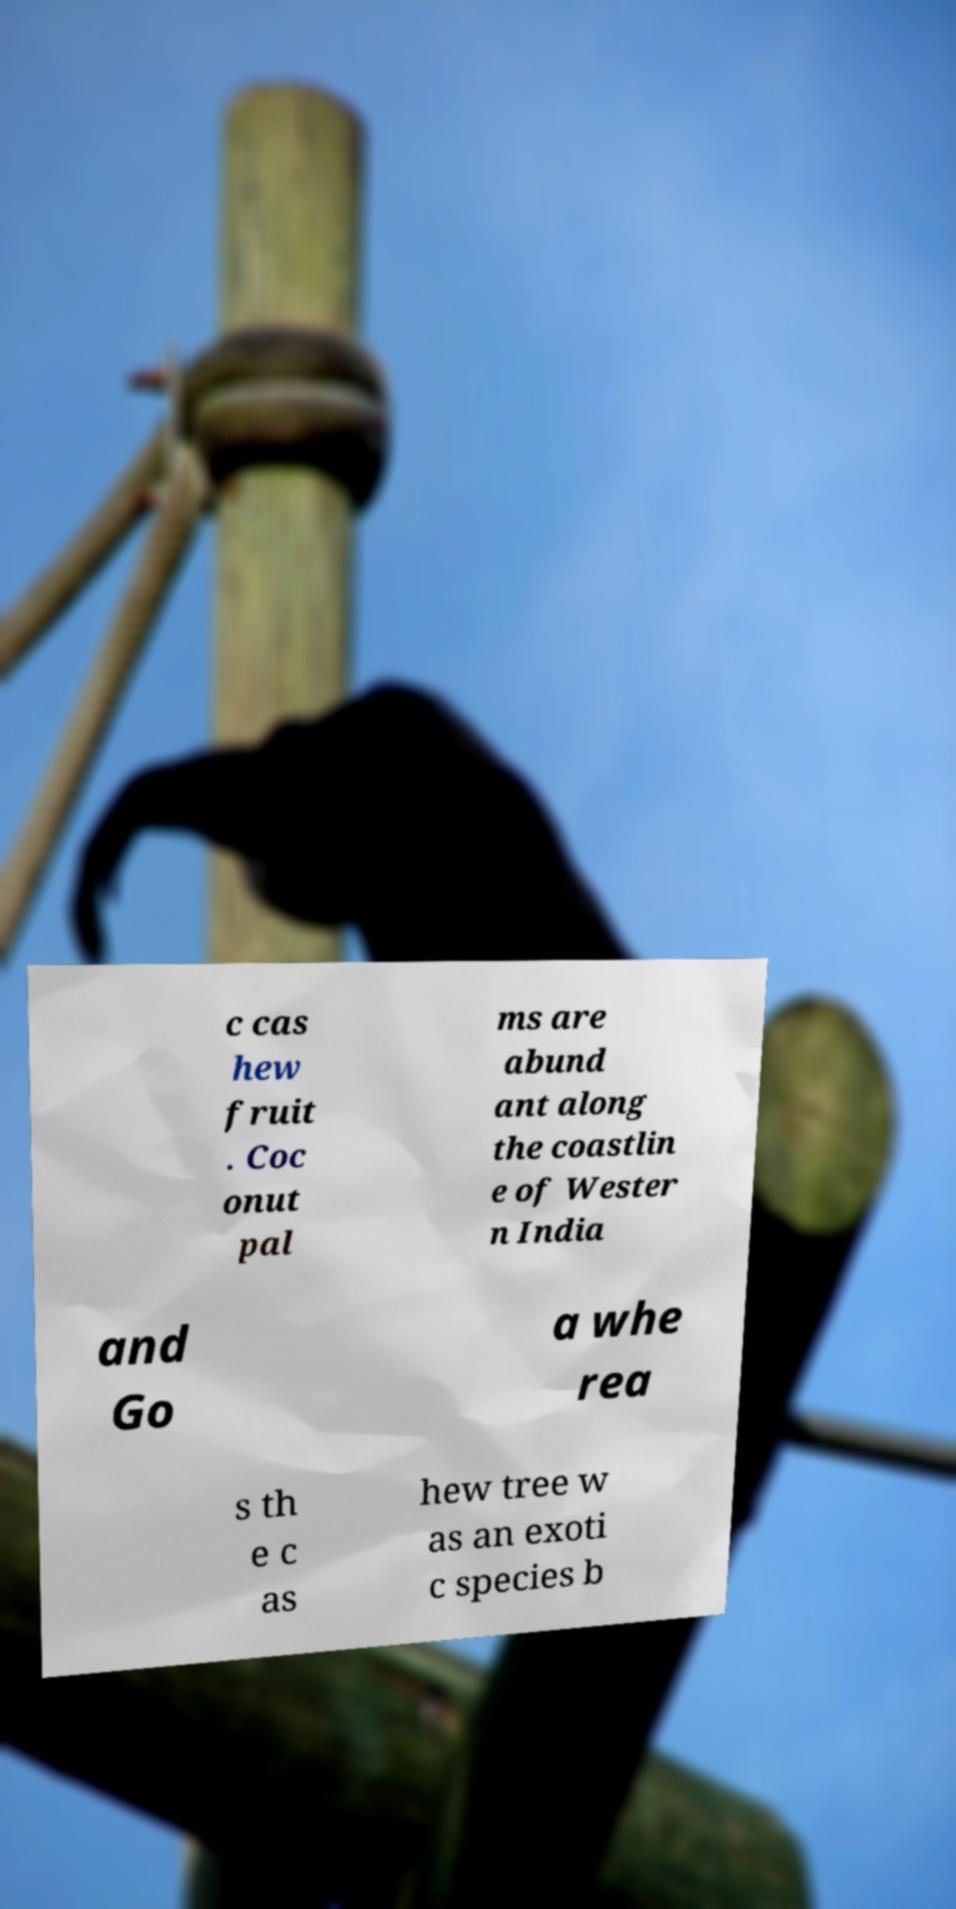Please read and relay the text visible in this image. What does it say? c cas hew fruit . Coc onut pal ms are abund ant along the coastlin e of Wester n India and Go a whe rea s th e c as hew tree w as an exoti c species b 